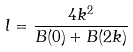<formula> <loc_0><loc_0><loc_500><loc_500>l = \frac { 4 k ^ { 2 } } { B ( 0 ) + B ( 2 k ) }</formula> 